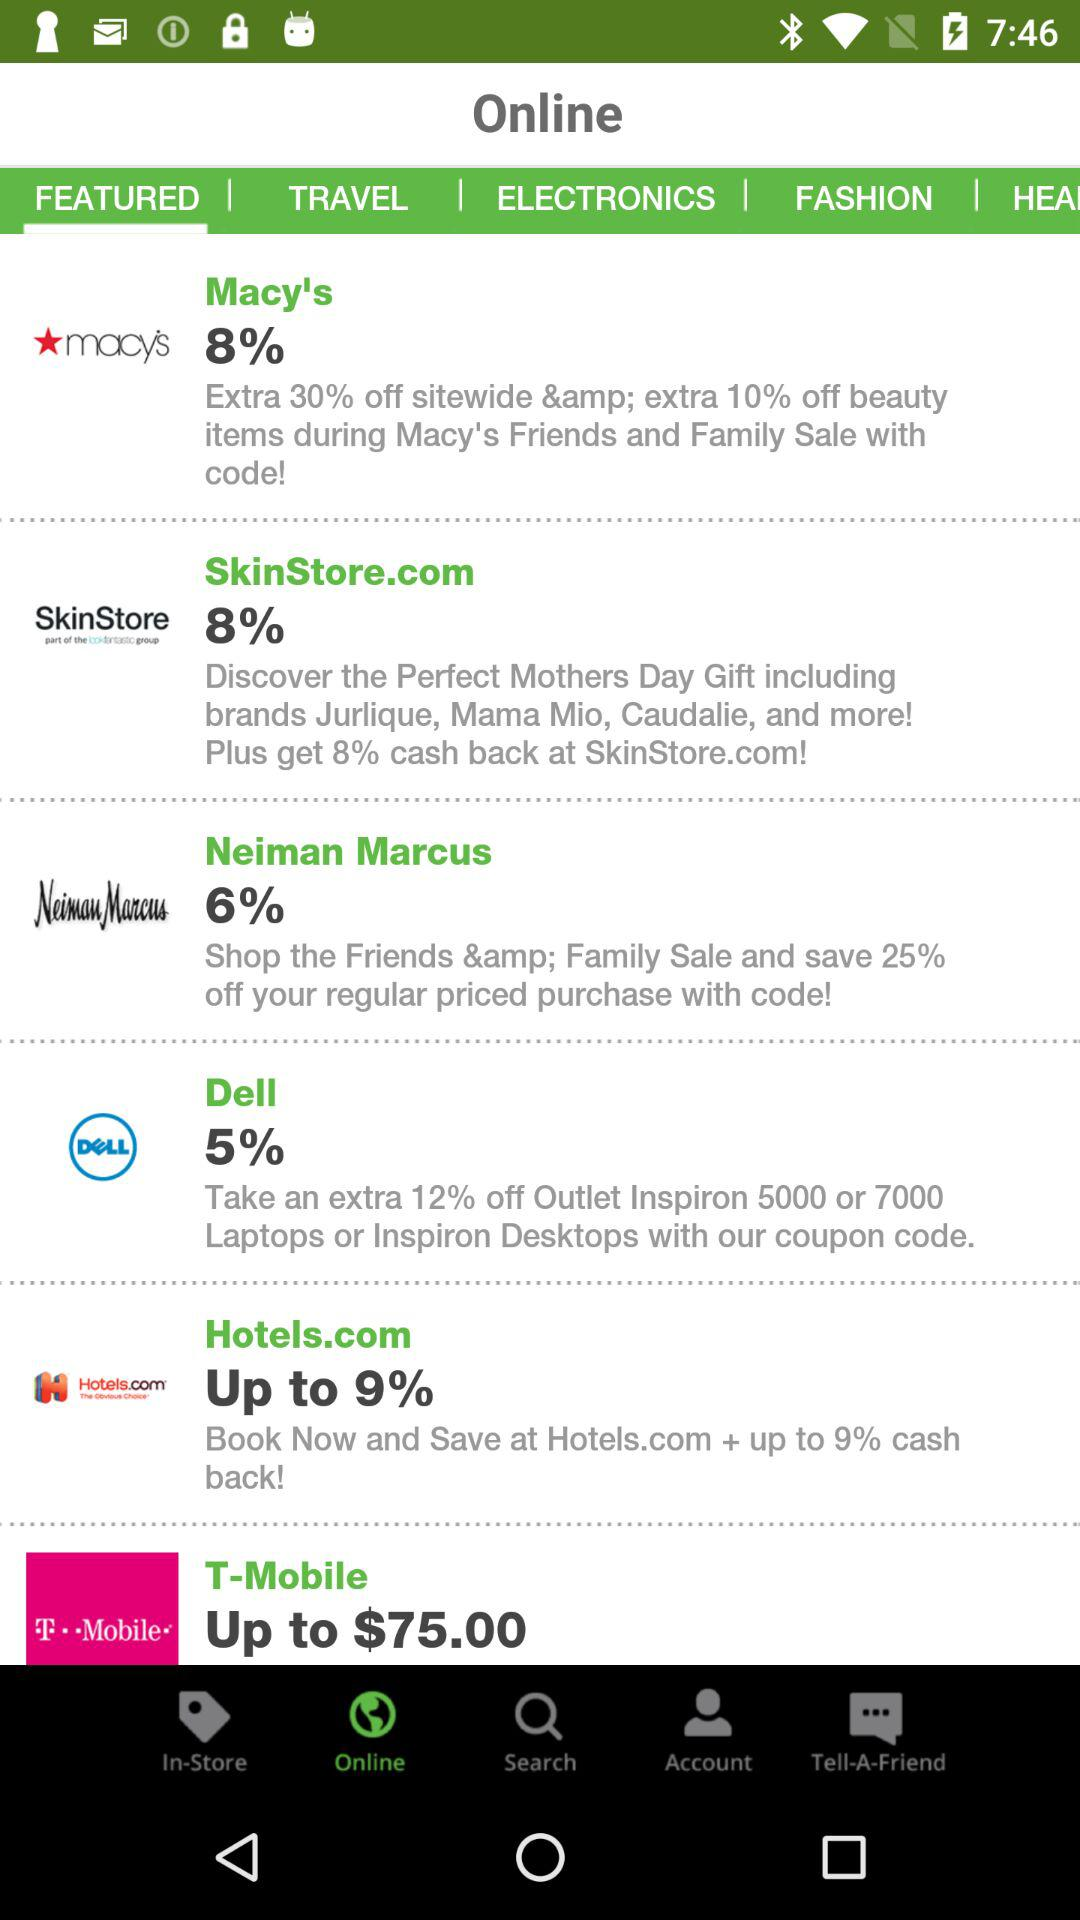Which tab is open? The open tabs are "Online" and "FEATURED". 